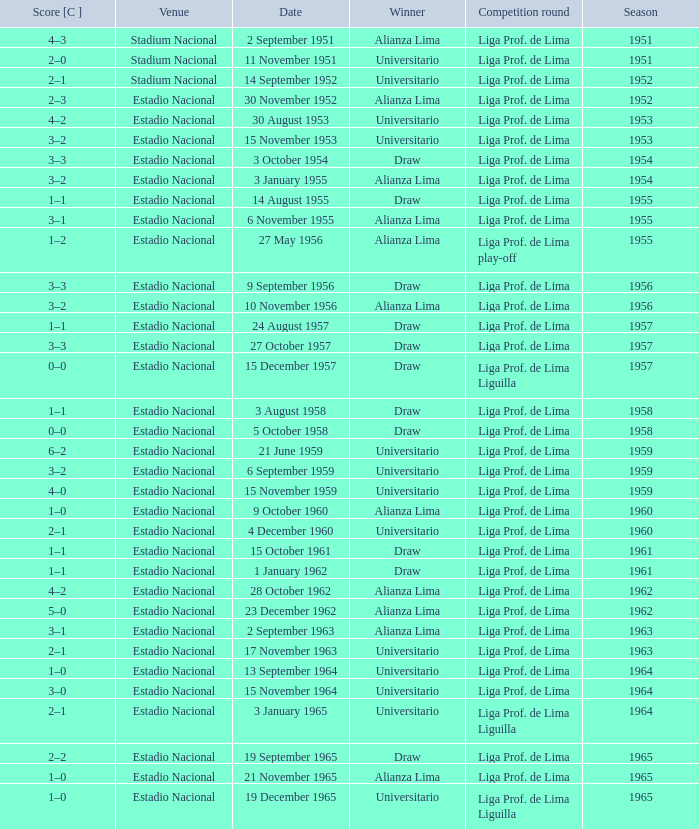What is the score of the event that Alianza Lima won in 1965? 1–0. 